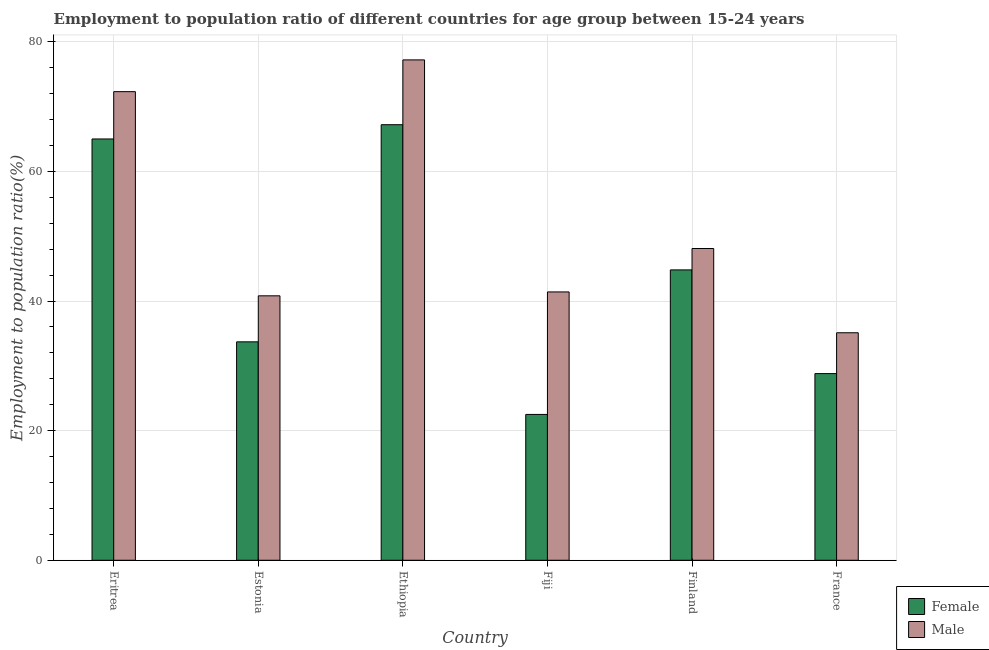How many groups of bars are there?
Make the answer very short. 6. Are the number of bars per tick equal to the number of legend labels?
Give a very brief answer. Yes. How many bars are there on the 2nd tick from the left?
Keep it short and to the point. 2. How many bars are there on the 2nd tick from the right?
Your answer should be very brief. 2. What is the label of the 6th group of bars from the left?
Offer a very short reply. France. What is the employment to population ratio(male) in Finland?
Your response must be concise. 48.1. Across all countries, what is the maximum employment to population ratio(male)?
Provide a succinct answer. 77.2. In which country was the employment to population ratio(female) maximum?
Offer a very short reply. Ethiopia. What is the total employment to population ratio(male) in the graph?
Your answer should be very brief. 314.9. What is the difference between the employment to population ratio(male) in Eritrea and that in Fiji?
Keep it short and to the point. 30.9. What is the difference between the employment to population ratio(male) in Ethiopia and the employment to population ratio(female) in France?
Your answer should be compact. 48.4. What is the average employment to population ratio(female) per country?
Your answer should be compact. 43.67. What is the difference between the employment to population ratio(female) and employment to population ratio(male) in France?
Keep it short and to the point. -6.3. In how many countries, is the employment to population ratio(female) greater than 40 %?
Your answer should be very brief. 3. What is the ratio of the employment to population ratio(male) in Ethiopia to that in France?
Your answer should be very brief. 2.2. What is the difference between the highest and the second highest employment to population ratio(female)?
Your answer should be very brief. 2.2. What is the difference between the highest and the lowest employment to population ratio(female)?
Make the answer very short. 44.7. In how many countries, is the employment to population ratio(female) greater than the average employment to population ratio(female) taken over all countries?
Your answer should be compact. 3. What does the 1st bar from the left in Estonia represents?
Ensure brevity in your answer.  Female. What does the 1st bar from the right in Fiji represents?
Give a very brief answer. Male. How many bars are there?
Offer a very short reply. 12. Are all the bars in the graph horizontal?
Give a very brief answer. No. How are the legend labels stacked?
Offer a terse response. Vertical. What is the title of the graph?
Keep it short and to the point. Employment to population ratio of different countries for age group between 15-24 years. Does "Pregnant women" appear as one of the legend labels in the graph?
Provide a short and direct response. No. What is the label or title of the Y-axis?
Your answer should be compact. Employment to population ratio(%). What is the Employment to population ratio(%) in Male in Eritrea?
Make the answer very short. 72.3. What is the Employment to population ratio(%) in Female in Estonia?
Offer a very short reply. 33.7. What is the Employment to population ratio(%) in Male in Estonia?
Provide a short and direct response. 40.8. What is the Employment to population ratio(%) in Female in Ethiopia?
Your answer should be very brief. 67.2. What is the Employment to population ratio(%) of Male in Ethiopia?
Provide a succinct answer. 77.2. What is the Employment to population ratio(%) in Male in Fiji?
Offer a very short reply. 41.4. What is the Employment to population ratio(%) in Female in Finland?
Give a very brief answer. 44.8. What is the Employment to population ratio(%) in Male in Finland?
Your answer should be compact. 48.1. What is the Employment to population ratio(%) in Female in France?
Your answer should be compact. 28.8. What is the Employment to population ratio(%) in Male in France?
Provide a succinct answer. 35.1. Across all countries, what is the maximum Employment to population ratio(%) in Female?
Give a very brief answer. 67.2. Across all countries, what is the maximum Employment to population ratio(%) in Male?
Ensure brevity in your answer.  77.2. Across all countries, what is the minimum Employment to population ratio(%) of Female?
Keep it short and to the point. 22.5. Across all countries, what is the minimum Employment to population ratio(%) in Male?
Your response must be concise. 35.1. What is the total Employment to population ratio(%) in Female in the graph?
Offer a terse response. 262. What is the total Employment to population ratio(%) of Male in the graph?
Keep it short and to the point. 314.9. What is the difference between the Employment to population ratio(%) in Female in Eritrea and that in Estonia?
Ensure brevity in your answer.  31.3. What is the difference between the Employment to population ratio(%) in Male in Eritrea and that in Estonia?
Give a very brief answer. 31.5. What is the difference between the Employment to population ratio(%) in Female in Eritrea and that in Ethiopia?
Offer a terse response. -2.2. What is the difference between the Employment to population ratio(%) of Male in Eritrea and that in Ethiopia?
Keep it short and to the point. -4.9. What is the difference between the Employment to population ratio(%) in Female in Eritrea and that in Fiji?
Keep it short and to the point. 42.5. What is the difference between the Employment to population ratio(%) of Male in Eritrea and that in Fiji?
Ensure brevity in your answer.  30.9. What is the difference between the Employment to population ratio(%) of Female in Eritrea and that in Finland?
Provide a short and direct response. 20.2. What is the difference between the Employment to population ratio(%) in Male in Eritrea and that in Finland?
Ensure brevity in your answer.  24.2. What is the difference between the Employment to population ratio(%) in Female in Eritrea and that in France?
Offer a terse response. 36.2. What is the difference between the Employment to population ratio(%) of Male in Eritrea and that in France?
Make the answer very short. 37.2. What is the difference between the Employment to population ratio(%) of Female in Estonia and that in Ethiopia?
Ensure brevity in your answer.  -33.5. What is the difference between the Employment to population ratio(%) of Male in Estonia and that in Ethiopia?
Ensure brevity in your answer.  -36.4. What is the difference between the Employment to population ratio(%) of Male in Estonia and that in Fiji?
Make the answer very short. -0.6. What is the difference between the Employment to population ratio(%) of Female in Estonia and that in Finland?
Give a very brief answer. -11.1. What is the difference between the Employment to population ratio(%) of Male in Estonia and that in Finland?
Give a very brief answer. -7.3. What is the difference between the Employment to population ratio(%) in Female in Ethiopia and that in Fiji?
Ensure brevity in your answer.  44.7. What is the difference between the Employment to population ratio(%) of Male in Ethiopia and that in Fiji?
Your answer should be very brief. 35.8. What is the difference between the Employment to population ratio(%) in Female in Ethiopia and that in Finland?
Provide a succinct answer. 22.4. What is the difference between the Employment to population ratio(%) of Male in Ethiopia and that in Finland?
Keep it short and to the point. 29.1. What is the difference between the Employment to population ratio(%) of Female in Ethiopia and that in France?
Offer a terse response. 38.4. What is the difference between the Employment to population ratio(%) in Male in Ethiopia and that in France?
Keep it short and to the point. 42.1. What is the difference between the Employment to population ratio(%) in Female in Fiji and that in Finland?
Offer a very short reply. -22.3. What is the difference between the Employment to population ratio(%) in Male in Fiji and that in Finland?
Make the answer very short. -6.7. What is the difference between the Employment to population ratio(%) of Female in Fiji and that in France?
Your answer should be compact. -6.3. What is the difference between the Employment to population ratio(%) in Male in Fiji and that in France?
Provide a succinct answer. 6.3. What is the difference between the Employment to population ratio(%) of Female in Eritrea and the Employment to population ratio(%) of Male in Estonia?
Make the answer very short. 24.2. What is the difference between the Employment to population ratio(%) in Female in Eritrea and the Employment to population ratio(%) in Male in Ethiopia?
Provide a short and direct response. -12.2. What is the difference between the Employment to population ratio(%) of Female in Eritrea and the Employment to population ratio(%) of Male in Fiji?
Offer a terse response. 23.6. What is the difference between the Employment to population ratio(%) in Female in Eritrea and the Employment to population ratio(%) in Male in France?
Ensure brevity in your answer.  29.9. What is the difference between the Employment to population ratio(%) of Female in Estonia and the Employment to population ratio(%) of Male in Ethiopia?
Your answer should be compact. -43.5. What is the difference between the Employment to population ratio(%) of Female in Estonia and the Employment to population ratio(%) of Male in Finland?
Make the answer very short. -14.4. What is the difference between the Employment to population ratio(%) in Female in Ethiopia and the Employment to population ratio(%) in Male in Fiji?
Your answer should be compact. 25.8. What is the difference between the Employment to population ratio(%) in Female in Ethiopia and the Employment to population ratio(%) in Male in France?
Your answer should be compact. 32.1. What is the difference between the Employment to population ratio(%) of Female in Fiji and the Employment to population ratio(%) of Male in Finland?
Offer a very short reply. -25.6. What is the difference between the Employment to population ratio(%) of Female in Fiji and the Employment to population ratio(%) of Male in France?
Provide a succinct answer. -12.6. What is the difference between the Employment to population ratio(%) of Female in Finland and the Employment to population ratio(%) of Male in France?
Make the answer very short. 9.7. What is the average Employment to population ratio(%) in Female per country?
Ensure brevity in your answer.  43.67. What is the average Employment to population ratio(%) of Male per country?
Provide a succinct answer. 52.48. What is the difference between the Employment to population ratio(%) of Female and Employment to population ratio(%) of Male in Ethiopia?
Offer a very short reply. -10. What is the difference between the Employment to population ratio(%) of Female and Employment to population ratio(%) of Male in Fiji?
Your response must be concise. -18.9. What is the ratio of the Employment to population ratio(%) of Female in Eritrea to that in Estonia?
Offer a terse response. 1.93. What is the ratio of the Employment to population ratio(%) of Male in Eritrea to that in Estonia?
Your response must be concise. 1.77. What is the ratio of the Employment to population ratio(%) in Female in Eritrea to that in Ethiopia?
Offer a terse response. 0.97. What is the ratio of the Employment to population ratio(%) in Male in Eritrea to that in Ethiopia?
Your answer should be compact. 0.94. What is the ratio of the Employment to population ratio(%) of Female in Eritrea to that in Fiji?
Offer a very short reply. 2.89. What is the ratio of the Employment to population ratio(%) of Male in Eritrea to that in Fiji?
Offer a terse response. 1.75. What is the ratio of the Employment to population ratio(%) of Female in Eritrea to that in Finland?
Provide a succinct answer. 1.45. What is the ratio of the Employment to population ratio(%) in Male in Eritrea to that in Finland?
Provide a short and direct response. 1.5. What is the ratio of the Employment to population ratio(%) of Female in Eritrea to that in France?
Your answer should be very brief. 2.26. What is the ratio of the Employment to population ratio(%) of Male in Eritrea to that in France?
Offer a terse response. 2.06. What is the ratio of the Employment to population ratio(%) in Female in Estonia to that in Ethiopia?
Offer a terse response. 0.5. What is the ratio of the Employment to population ratio(%) in Male in Estonia to that in Ethiopia?
Ensure brevity in your answer.  0.53. What is the ratio of the Employment to population ratio(%) in Female in Estonia to that in Fiji?
Provide a short and direct response. 1.5. What is the ratio of the Employment to population ratio(%) of Male in Estonia to that in Fiji?
Your answer should be very brief. 0.99. What is the ratio of the Employment to population ratio(%) of Female in Estonia to that in Finland?
Provide a short and direct response. 0.75. What is the ratio of the Employment to population ratio(%) of Male in Estonia to that in Finland?
Give a very brief answer. 0.85. What is the ratio of the Employment to population ratio(%) in Female in Estonia to that in France?
Give a very brief answer. 1.17. What is the ratio of the Employment to population ratio(%) of Male in Estonia to that in France?
Your answer should be compact. 1.16. What is the ratio of the Employment to population ratio(%) in Female in Ethiopia to that in Fiji?
Offer a very short reply. 2.99. What is the ratio of the Employment to population ratio(%) of Male in Ethiopia to that in Fiji?
Offer a terse response. 1.86. What is the ratio of the Employment to population ratio(%) of Female in Ethiopia to that in Finland?
Your response must be concise. 1.5. What is the ratio of the Employment to population ratio(%) in Male in Ethiopia to that in Finland?
Keep it short and to the point. 1.6. What is the ratio of the Employment to population ratio(%) of Female in Ethiopia to that in France?
Your answer should be very brief. 2.33. What is the ratio of the Employment to population ratio(%) in Male in Ethiopia to that in France?
Offer a terse response. 2.2. What is the ratio of the Employment to population ratio(%) in Female in Fiji to that in Finland?
Make the answer very short. 0.5. What is the ratio of the Employment to population ratio(%) of Male in Fiji to that in Finland?
Keep it short and to the point. 0.86. What is the ratio of the Employment to population ratio(%) in Female in Fiji to that in France?
Keep it short and to the point. 0.78. What is the ratio of the Employment to population ratio(%) of Male in Fiji to that in France?
Ensure brevity in your answer.  1.18. What is the ratio of the Employment to population ratio(%) of Female in Finland to that in France?
Your answer should be compact. 1.56. What is the ratio of the Employment to population ratio(%) of Male in Finland to that in France?
Your answer should be very brief. 1.37. What is the difference between the highest and the second highest Employment to population ratio(%) of Female?
Offer a terse response. 2.2. What is the difference between the highest and the second highest Employment to population ratio(%) of Male?
Make the answer very short. 4.9. What is the difference between the highest and the lowest Employment to population ratio(%) of Female?
Ensure brevity in your answer.  44.7. What is the difference between the highest and the lowest Employment to population ratio(%) of Male?
Keep it short and to the point. 42.1. 